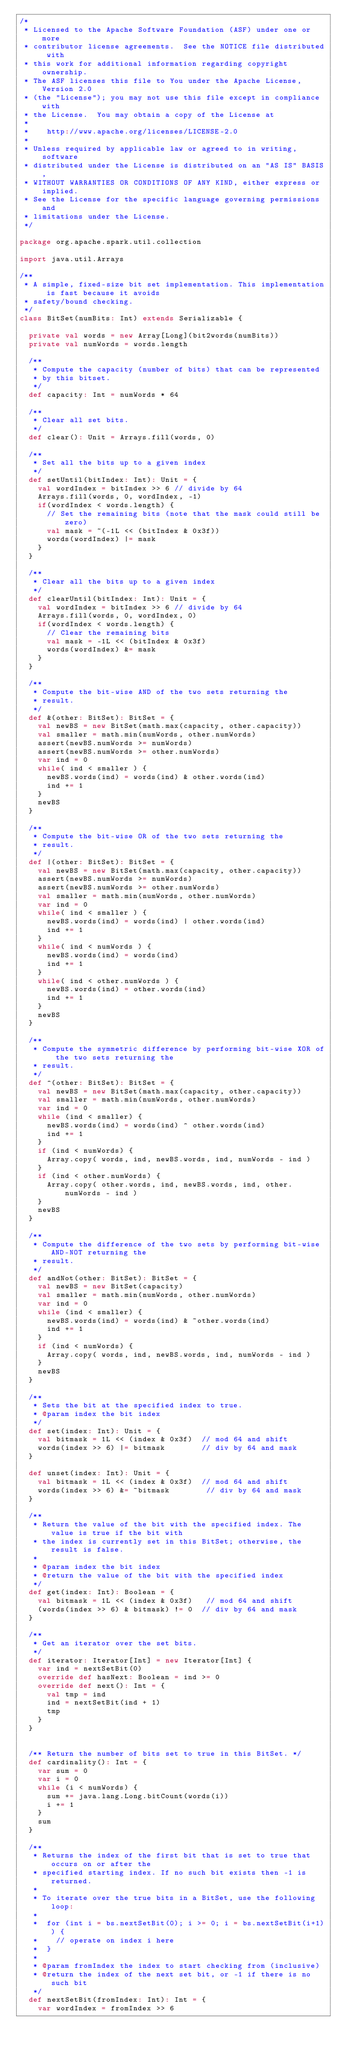<code> <loc_0><loc_0><loc_500><loc_500><_Scala_>/*
 * Licensed to the Apache Software Foundation (ASF) under one or more
 * contributor license agreements.  See the NOTICE file distributed with
 * this work for additional information regarding copyright ownership.
 * The ASF licenses this file to You under the Apache License, Version 2.0
 * (the "License"); you may not use this file except in compliance with
 * the License.  You may obtain a copy of the License at
 *
 *    http://www.apache.org/licenses/LICENSE-2.0
 *
 * Unless required by applicable law or agreed to in writing, software
 * distributed under the License is distributed on an "AS IS" BASIS,
 * WITHOUT WARRANTIES OR CONDITIONS OF ANY KIND, either express or implied.
 * See the License for the specific language governing permissions and
 * limitations under the License.
 */

package org.apache.spark.util.collection

import java.util.Arrays

/**
 * A simple, fixed-size bit set implementation. This implementation is fast because it avoids
 * safety/bound checking.
 */
class BitSet(numBits: Int) extends Serializable {

  private val words = new Array[Long](bit2words(numBits))
  private val numWords = words.length

  /**
   * Compute the capacity (number of bits) that can be represented
   * by this bitset.
   */
  def capacity: Int = numWords * 64

  /**
   * Clear all set bits.
   */
  def clear(): Unit = Arrays.fill(words, 0)

  /**
   * Set all the bits up to a given index
   */
  def setUntil(bitIndex: Int): Unit = {
    val wordIndex = bitIndex >> 6 // divide by 64
    Arrays.fill(words, 0, wordIndex, -1)
    if(wordIndex < words.length) {
      // Set the remaining bits (note that the mask could still be zero)
      val mask = ~(-1L << (bitIndex & 0x3f))
      words(wordIndex) |= mask
    }
  }

  /**
   * Clear all the bits up to a given index
   */
  def clearUntil(bitIndex: Int): Unit = {
    val wordIndex = bitIndex >> 6 // divide by 64
    Arrays.fill(words, 0, wordIndex, 0)
    if(wordIndex < words.length) {
      // Clear the remaining bits
      val mask = -1L << (bitIndex & 0x3f)
      words(wordIndex) &= mask
    }
  }

  /**
   * Compute the bit-wise AND of the two sets returning the
   * result.
   */
  def &(other: BitSet): BitSet = {
    val newBS = new BitSet(math.max(capacity, other.capacity))
    val smaller = math.min(numWords, other.numWords)
    assert(newBS.numWords >= numWords)
    assert(newBS.numWords >= other.numWords)
    var ind = 0
    while( ind < smaller ) {
      newBS.words(ind) = words(ind) & other.words(ind)
      ind += 1
    }
    newBS
  }

  /**
   * Compute the bit-wise OR of the two sets returning the
   * result.
   */
  def |(other: BitSet): BitSet = {
    val newBS = new BitSet(math.max(capacity, other.capacity))
    assert(newBS.numWords >= numWords)
    assert(newBS.numWords >= other.numWords)
    val smaller = math.min(numWords, other.numWords)
    var ind = 0
    while( ind < smaller ) {
      newBS.words(ind) = words(ind) | other.words(ind)
      ind += 1
    }
    while( ind < numWords ) {
      newBS.words(ind) = words(ind)
      ind += 1
    }
    while( ind < other.numWords ) {
      newBS.words(ind) = other.words(ind)
      ind += 1
    }
    newBS
  }

  /**
   * Compute the symmetric difference by performing bit-wise XOR of the two sets returning the
   * result.
   */
  def ^(other: BitSet): BitSet = {
    val newBS = new BitSet(math.max(capacity, other.capacity))
    val smaller = math.min(numWords, other.numWords)
    var ind = 0
    while (ind < smaller) {
      newBS.words(ind) = words(ind) ^ other.words(ind)
      ind += 1
    }
    if (ind < numWords) {
      Array.copy( words, ind, newBS.words, ind, numWords - ind )
    }
    if (ind < other.numWords) {
      Array.copy( other.words, ind, newBS.words, ind, other.numWords - ind )
    }
    newBS
  }

  /**
   * Compute the difference of the two sets by performing bit-wise AND-NOT returning the
   * result.
   */
  def andNot(other: BitSet): BitSet = {
    val newBS = new BitSet(capacity)
    val smaller = math.min(numWords, other.numWords)
    var ind = 0
    while (ind < smaller) {
      newBS.words(ind) = words(ind) & ~other.words(ind)
      ind += 1
    }
    if (ind < numWords) {
      Array.copy( words, ind, newBS.words, ind, numWords - ind )
    }
    newBS
  }

  /**
   * Sets the bit at the specified index to true.
   * @param index the bit index
   */
  def set(index: Int): Unit = {
    val bitmask = 1L << (index & 0x3f)  // mod 64 and shift
    words(index >> 6) |= bitmask        // div by 64 and mask
  }

  def unset(index: Int): Unit = {
    val bitmask = 1L << (index & 0x3f)  // mod 64 and shift
    words(index >> 6) &= ~bitmask        // div by 64 and mask
  }

  /**
   * Return the value of the bit with the specified index. The value is true if the bit with
   * the index is currently set in this BitSet; otherwise, the result is false.
   *
   * @param index the bit index
   * @return the value of the bit with the specified index
   */
  def get(index: Int): Boolean = {
    val bitmask = 1L << (index & 0x3f)   // mod 64 and shift
    (words(index >> 6) & bitmask) != 0  // div by 64 and mask
  }

  /**
   * Get an iterator over the set bits.
   */
  def iterator: Iterator[Int] = new Iterator[Int] {
    var ind = nextSetBit(0)
    override def hasNext: Boolean = ind >= 0
    override def next(): Int = {
      val tmp = ind
      ind = nextSetBit(ind + 1)
      tmp
    }
  }


  /** Return the number of bits set to true in this BitSet. */
  def cardinality(): Int = {
    var sum = 0
    var i = 0
    while (i < numWords) {
      sum += java.lang.Long.bitCount(words(i))
      i += 1
    }
    sum
  }

  /**
   * Returns the index of the first bit that is set to true that occurs on or after the
   * specified starting index. If no such bit exists then -1 is returned.
   *
   * To iterate over the true bits in a BitSet, use the following loop:
   *
   *  for (int i = bs.nextSetBit(0); i >= 0; i = bs.nextSetBit(i+1)) {
   *    // operate on index i here
   *  }
   *
   * @param fromIndex the index to start checking from (inclusive)
   * @return the index of the next set bit, or -1 if there is no such bit
   */
  def nextSetBit(fromIndex: Int): Int = {
    var wordIndex = fromIndex >> 6</code> 